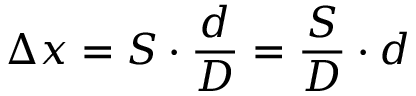<formula> <loc_0><loc_0><loc_500><loc_500>\Delta x = S \cdot { \frac { d } { D } } = { \frac { S } { D } } \cdot d</formula> 